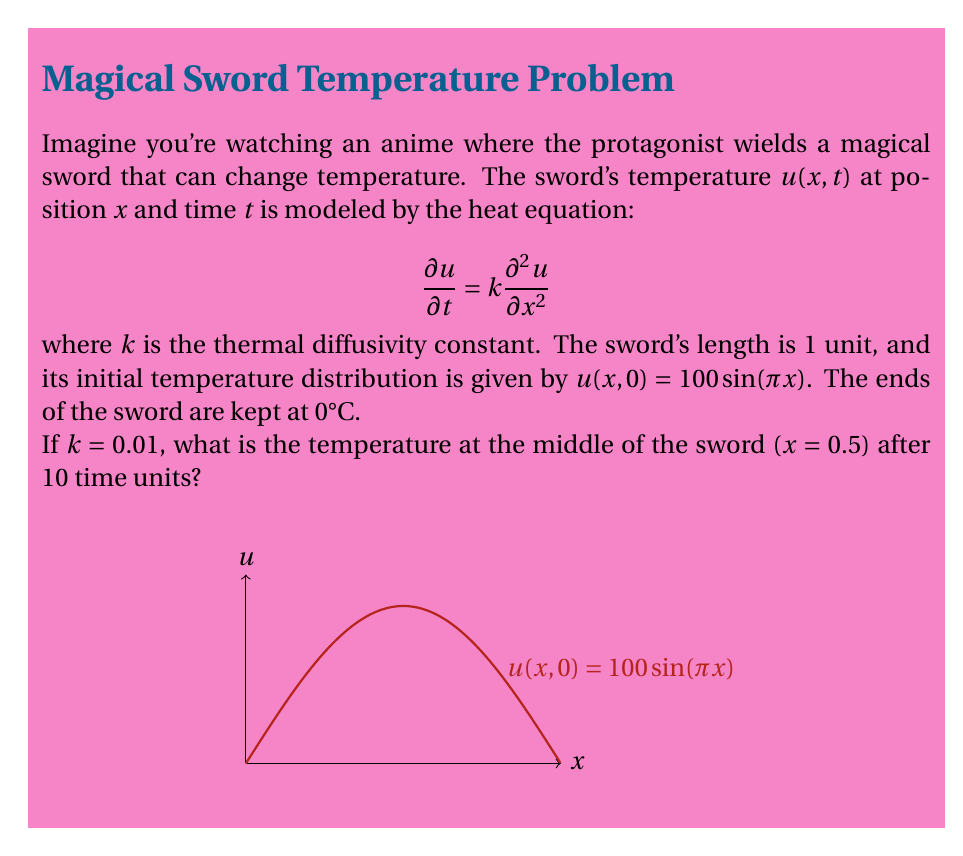Can you solve this math problem? Let's solve this step-by-step:

1) The general solution to the heat equation with these boundary conditions is:

   $$u(x,t) = \sum_{n=1}^{\infty} B_n \sin(n\pi x) e^{-kn^2\pi^2t}$$

2) Given the initial condition $u(x,0) = 100\sin(\pi x)$, we can see that only the first term of the series is non-zero, with $B_1 = 100$ and $B_n = 0$ for $n > 1$.

3) Therefore, our solution simplifies to:

   $$u(x,t) = 100 \sin(\pi x) e^{-k\pi^2t}$$

4) We're asked about the point $x = 0.5$ (middle of the sword) at time $t = 10$, with $k = 0.01$. Let's substitute these values:

   $$u(0.5, 10) = 100 \sin(\pi \cdot 0.5) e^{-0.01\pi^2 \cdot 10}$$

5) Simplify:
   - $\sin(\pi \cdot 0.5) = \sin(\pi/2) = 1$
   - $e^{-0.01\pi^2 \cdot 10} \approx 0.3742$

6) Calculate:

   $$u(0.5, 10) = 100 \cdot 1 \cdot 0.3742 = 37.42$$

Therefore, the temperature at the middle of the sword after 10 time units is approximately 37.42°C.
Answer: 37.42°C 